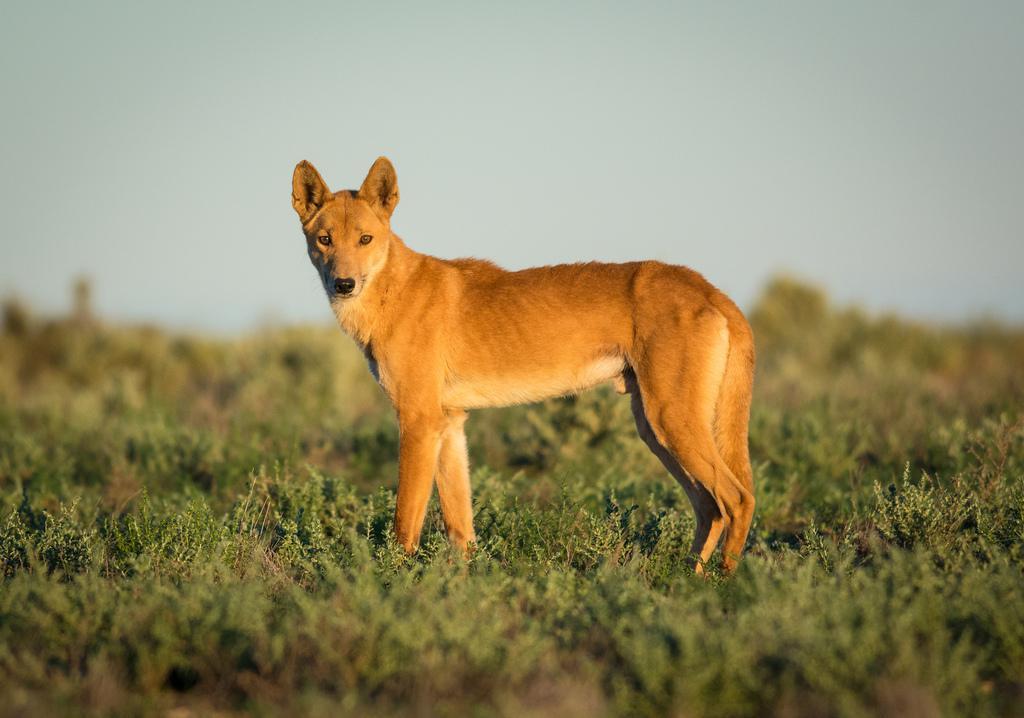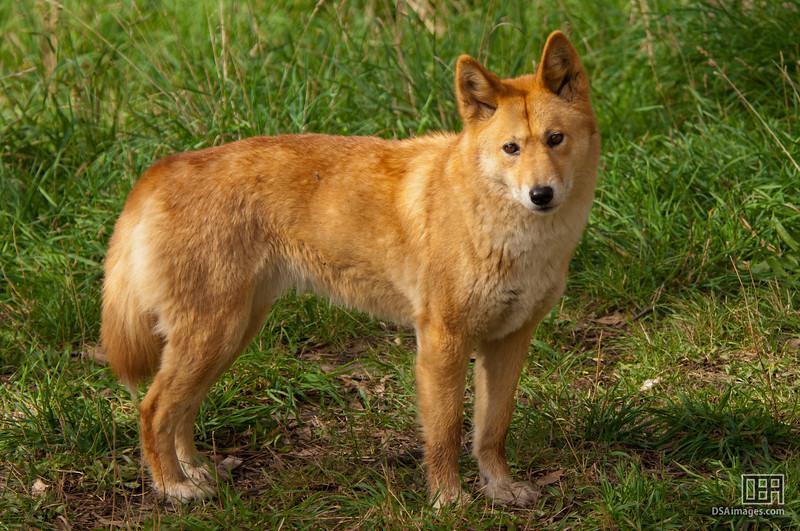The first image is the image on the left, the second image is the image on the right. Considering the images on both sides, is "There are exactly two wild dogs." valid? Answer yes or no. Yes. The first image is the image on the left, the second image is the image on the right. Considering the images on both sides, is "An image includes an adult dingo standing by at least three juvenile dogs." valid? Answer yes or no. No. 